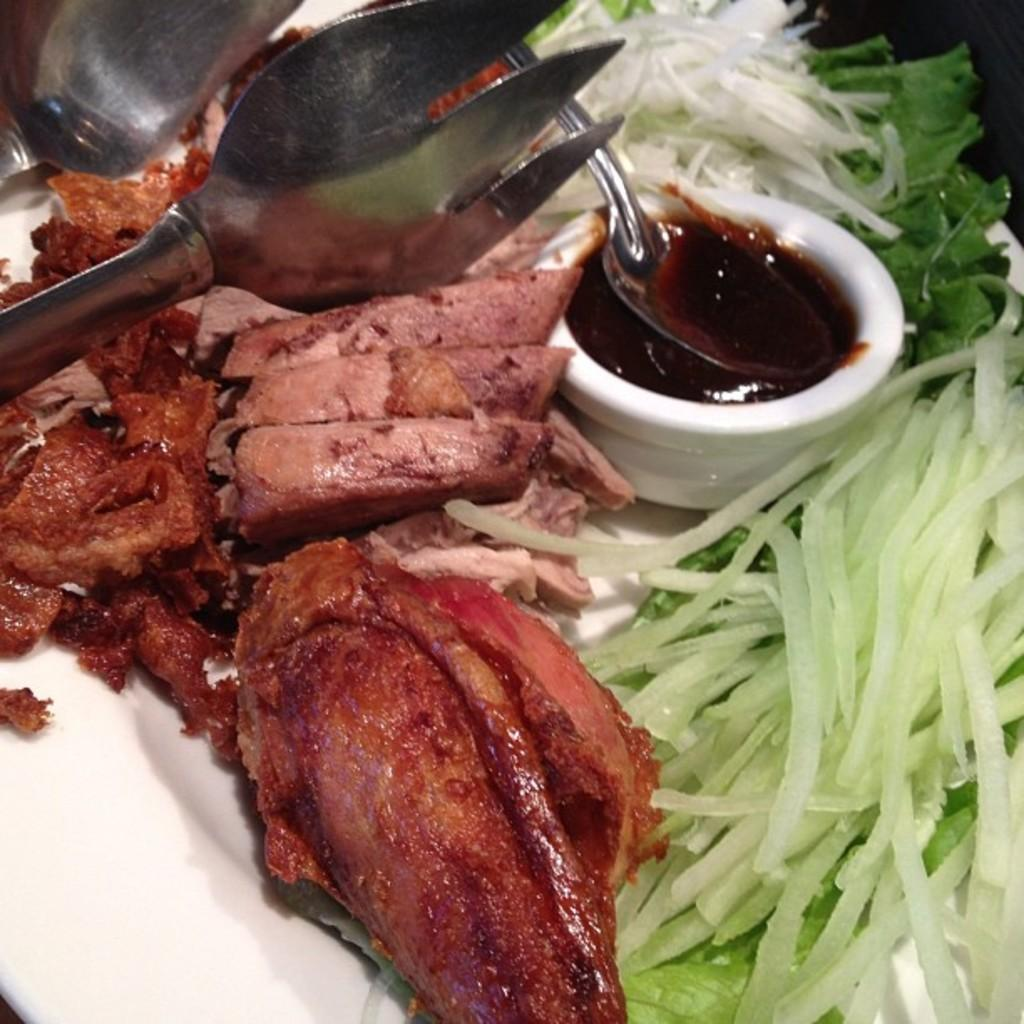What is on the plate in the image? There is food in a plate in the image. What is in the cup in the image? There is a spoon in a cup in the image. What utensil is present in the image? There is a serving tong in the image. How many tomatoes are on the plate in the image? There is no information about tomatoes in the image, so we cannot determine the number of tomatoes. What type of lumber is used to make the spoon in the image? There is no information about the spoon being made of lumber in the image, so we cannot determine the type of lumber used. 